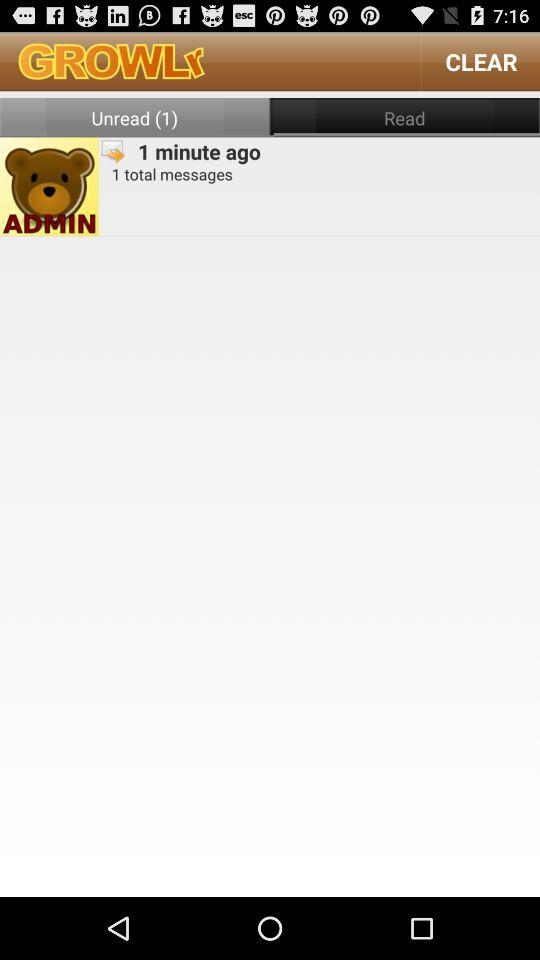Which tab is selected? The selected tab is "Read". 